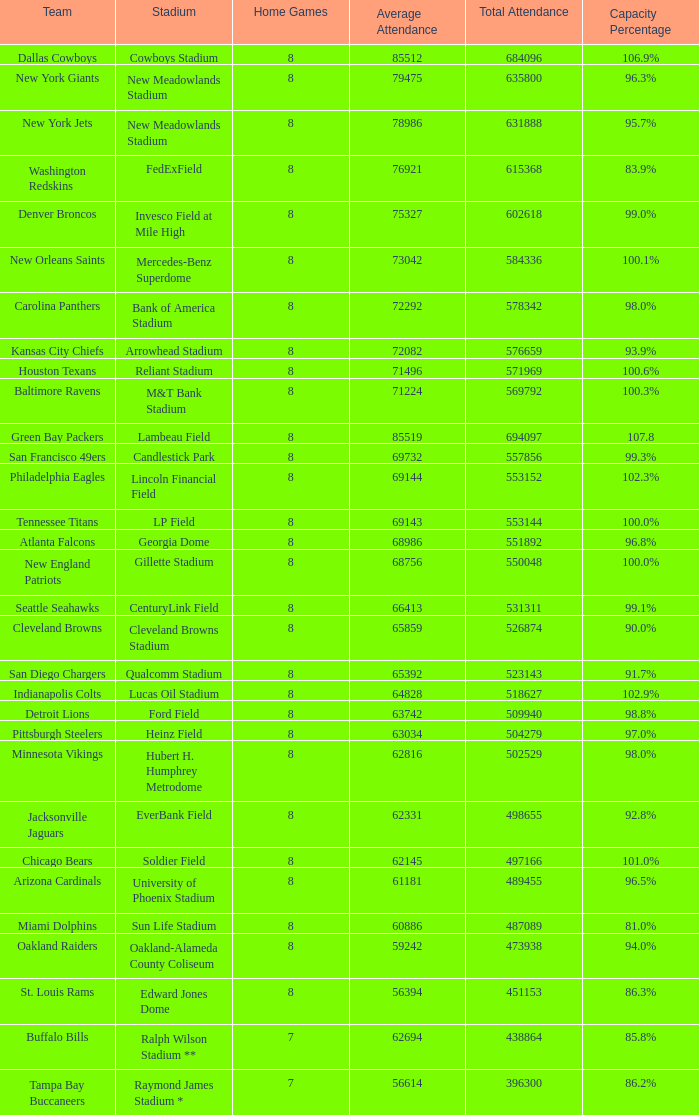How many average attendance has a capacity percentage of 96.5% 1.0. 